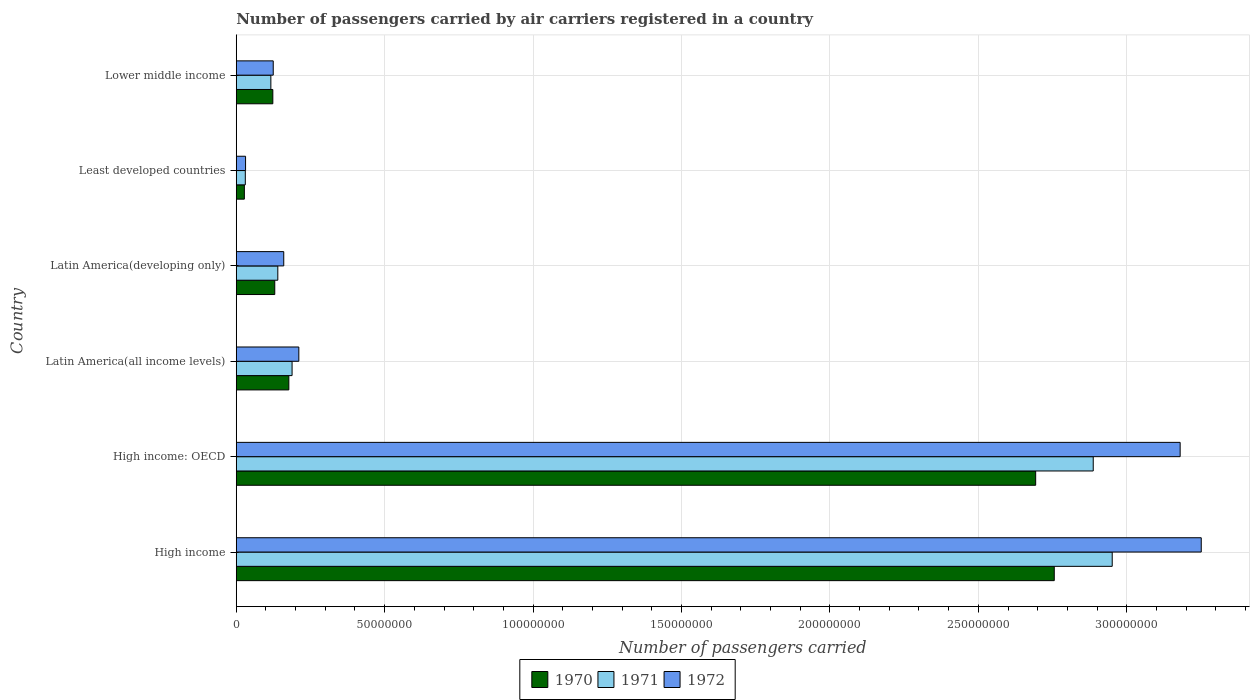Are the number of bars per tick equal to the number of legend labels?
Ensure brevity in your answer.  Yes. How many bars are there on the 1st tick from the top?
Your answer should be compact. 3. What is the label of the 5th group of bars from the top?
Make the answer very short. High income: OECD. What is the number of passengers carried by air carriers in 1971 in Latin America(developing only)?
Give a very brief answer. 1.40e+07. Across all countries, what is the maximum number of passengers carried by air carriers in 1970?
Provide a succinct answer. 2.76e+08. Across all countries, what is the minimum number of passengers carried by air carriers in 1972?
Your answer should be compact. 3.14e+06. In which country was the number of passengers carried by air carriers in 1972 maximum?
Ensure brevity in your answer.  High income. In which country was the number of passengers carried by air carriers in 1970 minimum?
Offer a terse response. Least developed countries. What is the total number of passengers carried by air carriers in 1970 in the graph?
Keep it short and to the point. 5.91e+08. What is the difference between the number of passengers carried by air carriers in 1972 in High income and that in Lower middle income?
Ensure brevity in your answer.  3.13e+08. What is the difference between the number of passengers carried by air carriers in 1970 in Latin America(all income levels) and the number of passengers carried by air carriers in 1972 in Latin America(developing only)?
Offer a terse response. 1.71e+06. What is the average number of passengers carried by air carriers in 1971 per country?
Your response must be concise. 1.05e+08. What is the difference between the number of passengers carried by air carriers in 1972 and number of passengers carried by air carriers in 1970 in Lower middle income?
Provide a short and direct response. 1.41e+05. What is the ratio of the number of passengers carried by air carriers in 1972 in Latin America(all income levels) to that in Least developed countries?
Your response must be concise. 6.72. Is the number of passengers carried by air carriers in 1970 in High income: OECD less than that in Lower middle income?
Keep it short and to the point. No. What is the difference between the highest and the second highest number of passengers carried by air carriers in 1970?
Offer a very short reply. 6.26e+06. What is the difference between the highest and the lowest number of passengers carried by air carriers in 1971?
Provide a short and direct response. 2.92e+08. Is the sum of the number of passengers carried by air carriers in 1970 in High income and Latin America(developing only) greater than the maximum number of passengers carried by air carriers in 1972 across all countries?
Your answer should be very brief. No. What does the 3rd bar from the top in Latin America(all income levels) represents?
Ensure brevity in your answer.  1970. What does the 1st bar from the bottom in High income represents?
Ensure brevity in your answer.  1970. How many bars are there?
Provide a succinct answer. 18. What is the difference between two consecutive major ticks on the X-axis?
Offer a terse response. 5.00e+07. How many legend labels are there?
Provide a short and direct response. 3. What is the title of the graph?
Give a very brief answer. Number of passengers carried by air carriers registered in a country. Does "1992" appear as one of the legend labels in the graph?
Provide a succinct answer. No. What is the label or title of the X-axis?
Provide a succinct answer. Number of passengers carried. What is the Number of passengers carried in 1970 in High income?
Your answer should be very brief. 2.76e+08. What is the Number of passengers carried of 1971 in High income?
Offer a terse response. 2.95e+08. What is the Number of passengers carried of 1972 in High income?
Ensure brevity in your answer.  3.25e+08. What is the Number of passengers carried of 1970 in High income: OECD?
Provide a succinct answer. 2.69e+08. What is the Number of passengers carried in 1971 in High income: OECD?
Offer a terse response. 2.89e+08. What is the Number of passengers carried in 1972 in High income: OECD?
Ensure brevity in your answer.  3.18e+08. What is the Number of passengers carried in 1970 in Latin America(all income levels)?
Offer a very short reply. 1.77e+07. What is the Number of passengers carried in 1971 in Latin America(all income levels)?
Offer a very short reply. 1.88e+07. What is the Number of passengers carried of 1972 in Latin America(all income levels)?
Your response must be concise. 2.11e+07. What is the Number of passengers carried of 1970 in Latin America(developing only)?
Your response must be concise. 1.30e+07. What is the Number of passengers carried in 1971 in Latin America(developing only)?
Your response must be concise. 1.40e+07. What is the Number of passengers carried of 1972 in Latin America(developing only)?
Offer a very short reply. 1.60e+07. What is the Number of passengers carried of 1970 in Least developed countries?
Your answer should be very brief. 2.73e+06. What is the Number of passengers carried of 1971 in Least developed countries?
Offer a very short reply. 3.05e+06. What is the Number of passengers carried of 1972 in Least developed countries?
Provide a succinct answer. 3.14e+06. What is the Number of passengers carried in 1970 in Lower middle income?
Make the answer very short. 1.23e+07. What is the Number of passengers carried of 1971 in Lower middle income?
Give a very brief answer. 1.17e+07. What is the Number of passengers carried of 1972 in Lower middle income?
Your answer should be compact. 1.25e+07. Across all countries, what is the maximum Number of passengers carried of 1970?
Keep it short and to the point. 2.76e+08. Across all countries, what is the maximum Number of passengers carried in 1971?
Offer a very short reply. 2.95e+08. Across all countries, what is the maximum Number of passengers carried of 1972?
Your answer should be compact. 3.25e+08. Across all countries, what is the minimum Number of passengers carried of 1970?
Offer a very short reply. 2.73e+06. Across all countries, what is the minimum Number of passengers carried in 1971?
Provide a short and direct response. 3.05e+06. Across all countries, what is the minimum Number of passengers carried of 1972?
Your answer should be very brief. 3.14e+06. What is the total Number of passengers carried of 1970 in the graph?
Keep it short and to the point. 5.91e+08. What is the total Number of passengers carried in 1971 in the graph?
Provide a short and direct response. 6.31e+08. What is the total Number of passengers carried in 1972 in the graph?
Your response must be concise. 6.96e+08. What is the difference between the Number of passengers carried in 1970 in High income and that in High income: OECD?
Ensure brevity in your answer.  6.26e+06. What is the difference between the Number of passengers carried of 1971 in High income and that in High income: OECD?
Give a very brief answer. 6.40e+06. What is the difference between the Number of passengers carried of 1972 in High income and that in High income: OECD?
Keep it short and to the point. 7.11e+06. What is the difference between the Number of passengers carried of 1970 in High income and that in Latin America(all income levels)?
Offer a very short reply. 2.58e+08. What is the difference between the Number of passengers carried in 1971 in High income and that in Latin America(all income levels)?
Make the answer very short. 2.76e+08. What is the difference between the Number of passengers carried of 1972 in High income and that in Latin America(all income levels)?
Your response must be concise. 3.04e+08. What is the difference between the Number of passengers carried in 1970 in High income and that in Latin America(developing only)?
Provide a succinct answer. 2.63e+08. What is the difference between the Number of passengers carried of 1971 in High income and that in Latin America(developing only)?
Provide a succinct answer. 2.81e+08. What is the difference between the Number of passengers carried of 1972 in High income and that in Latin America(developing only)?
Provide a succinct answer. 3.09e+08. What is the difference between the Number of passengers carried in 1970 in High income and that in Least developed countries?
Give a very brief answer. 2.73e+08. What is the difference between the Number of passengers carried in 1971 in High income and that in Least developed countries?
Your answer should be very brief. 2.92e+08. What is the difference between the Number of passengers carried of 1972 in High income and that in Least developed countries?
Make the answer very short. 3.22e+08. What is the difference between the Number of passengers carried of 1970 in High income and that in Lower middle income?
Your response must be concise. 2.63e+08. What is the difference between the Number of passengers carried of 1971 in High income and that in Lower middle income?
Provide a short and direct response. 2.83e+08. What is the difference between the Number of passengers carried in 1972 in High income and that in Lower middle income?
Keep it short and to the point. 3.13e+08. What is the difference between the Number of passengers carried in 1970 in High income: OECD and that in Latin America(all income levels)?
Your answer should be very brief. 2.52e+08. What is the difference between the Number of passengers carried in 1971 in High income: OECD and that in Latin America(all income levels)?
Your answer should be very brief. 2.70e+08. What is the difference between the Number of passengers carried in 1972 in High income: OECD and that in Latin America(all income levels)?
Your response must be concise. 2.97e+08. What is the difference between the Number of passengers carried of 1970 in High income: OECD and that in Latin America(developing only)?
Offer a terse response. 2.56e+08. What is the difference between the Number of passengers carried of 1971 in High income: OECD and that in Latin America(developing only)?
Give a very brief answer. 2.75e+08. What is the difference between the Number of passengers carried in 1972 in High income: OECD and that in Latin America(developing only)?
Make the answer very short. 3.02e+08. What is the difference between the Number of passengers carried of 1970 in High income: OECD and that in Least developed countries?
Give a very brief answer. 2.67e+08. What is the difference between the Number of passengers carried of 1971 in High income: OECD and that in Least developed countries?
Provide a succinct answer. 2.86e+08. What is the difference between the Number of passengers carried of 1972 in High income: OECD and that in Least developed countries?
Provide a succinct answer. 3.15e+08. What is the difference between the Number of passengers carried in 1970 in High income: OECD and that in Lower middle income?
Keep it short and to the point. 2.57e+08. What is the difference between the Number of passengers carried of 1971 in High income: OECD and that in Lower middle income?
Offer a terse response. 2.77e+08. What is the difference between the Number of passengers carried in 1972 in High income: OECD and that in Lower middle income?
Your answer should be very brief. 3.06e+08. What is the difference between the Number of passengers carried in 1970 in Latin America(all income levels) and that in Latin America(developing only)?
Provide a succinct answer. 4.74e+06. What is the difference between the Number of passengers carried in 1971 in Latin America(all income levels) and that in Latin America(developing only)?
Your response must be concise. 4.81e+06. What is the difference between the Number of passengers carried in 1972 in Latin America(all income levels) and that in Latin America(developing only)?
Offer a terse response. 5.08e+06. What is the difference between the Number of passengers carried of 1970 in Latin America(all income levels) and that in Least developed countries?
Provide a succinct answer. 1.50e+07. What is the difference between the Number of passengers carried in 1971 in Latin America(all income levels) and that in Least developed countries?
Offer a terse response. 1.58e+07. What is the difference between the Number of passengers carried of 1972 in Latin America(all income levels) and that in Least developed countries?
Make the answer very short. 1.79e+07. What is the difference between the Number of passengers carried in 1970 in Latin America(all income levels) and that in Lower middle income?
Offer a terse response. 5.40e+06. What is the difference between the Number of passengers carried of 1971 in Latin America(all income levels) and that in Lower middle income?
Provide a succinct answer. 7.15e+06. What is the difference between the Number of passengers carried of 1972 in Latin America(all income levels) and that in Lower middle income?
Keep it short and to the point. 8.62e+06. What is the difference between the Number of passengers carried in 1970 in Latin America(developing only) and that in Least developed countries?
Make the answer very short. 1.02e+07. What is the difference between the Number of passengers carried of 1971 in Latin America(developing only) and that in Least developed countries?
Provide a succinct answer. 1.09e+07. What is the difference between the Number of passengers carried in 1972 in Latin America(developing only) and that in Least developed countries?
Offer a very short reply. 1.29e+07. What is the difference between the Number of passengers carried in 1970 in Latin America(developing only) and that in Lower middle income?
Provide a short and direct response. 6.57e+05. What is the difference between the Number of passengers carried of 1971 in Latin America(developing only) and that in Lower middle income?
Make the answer very short. 2.35e+06. What is the difference between the Number of passengers carried of 1972 in Latin America(developing only) and that in Lower middle income?
Your answer should be very brief. 3.54e+06. What is the difference between the Number of passengers carried of 1970 in Least developed countries and that in Lower middle income?
Offer a terse response. -9.59e+06. What is the difference between the Number of passengers carried of 1971 in Least developed countries and that in Lower middle income?
Your answer should be very brief. -8.60e+06. What is the difference between the Number of passengers carried of 1972 in Least developed countries and that in Lower middle income?
Make the answer very short. -9.32e+06. What is the difference between the Number of passengers carried in 1970 in High income and the Number of passengers carried in 1971 in High income: OECD?
Your answer should be compact. -1.31e+07. What is the difference between the Number of passengers carried of 1970 in High income and the Number of passengers carried of 1972 in High income: OECD?
Offer a terse response. -4.24e+07. What is the difference between the Number of passengers carried of 1971 in High income and the Number of passengers carried of 1972 in High income: OECD?
Offer a very short reply. -2.29e+07. What is the difference between the Number of passengers carried in 1970 in High income and the Number of passengers carried in 1971 in Latin America(all income levels)?
Ensure brevity in your answer.  2.57e+08. What is the difference between the Number of passengers carried of 1970 in High income and the Number of passengers carried of 1972 in Latin America(all income levels)?
Offer a very short reply. 2.55e+08. What is the difference between the Number of passengers carried of 1971 in High income and the Number of passengers carried of 1972 in Latin America(all income levels)?
Provide a succinct answer. 2.74e+08. What is the difference between the Number of passengers carried in 1970 in High income and the Number of passengers carried in 1971 in Latin America(developing only)?
Your response must be concise. 2.62e+08. What is the difference between the Number of passengers carried of 1970 in High income and the Number of passengers carried of 1972 in Latin America(developing only)?
Ensure brevity in your answer.  2.60e+08. What is the difference between the Number of passengers carried of 1971 in High income and the Number of passengers carried of 1972 in Latin America(developing only)?
Offer a very short reply. 2.79e+08. What is the difference between the Number of passengers carried of 1970 in High income and the Number of passengers carried of 1971 in Least developed countries?
Ensure brevity in your answer.  2.73e+08. What is the difference between the Number of passengers carried of 1970 in High income and the Number of passengers carried of 1972 in Least developed countries?
Offer a terse response. 2.72e+08. What is the difference between the Number of passengers carried of 1971 in High income and the Number of passengers carried of 1972 in Least developed countries?
Keep it short and to the point. 2.92e+08. What is the difference between the Number of passengers carried of 1970 in High income and the Number of passengers carried of 1971 in Lower middle income?
Offer a very short reply. 2.64e+08. What is the difference between the Number of passengers carried of 1970 in High income and the Number of passengers carried of 1972 in Lower middle income?
Provide a short and direct response. 2.63e+08. What is the difference between the Number of passengers carried of 1971 in High income and the Number of passengers carried of 1972 in Lower middle income?
Ensure brevity in your answer.  2.83e+08. What is the difference between the Number of passengers carried in 1970 in High income: OECD and the Number of passengers carried in 1971 in Latin America(all income levels)?
Offer a very short reply. 2.51e+08. What is the difference between the Number of passengers carried of 1970 in High income: OECD and the Number of passengers carried of 1972 in Latin America(all income levels)?
Give a very brief answer. 2.48e+08. What is the difference between the Number of passengers carried in 1971 in High income: OECD and the Number of passengers carried in 1972 in Latin America(all income levels)?
Provide a short and direct response. 2.68e+08. What is the difference between the Number of passengers carried in 1970 in High income: OECD and the Number of passengers carried in 1971 in Latin America(developing only)?
Your answer should be very brief. 2.55e+08. What is the difference between the Number of passengers carried in 1970 in High income: OECD and the Number of passengers carried in 1972 in Latin America(developing only)?
Your answer should be compact. 2.53e+08. What is the difference between the Number of passengers carried of 1971 in High income: OECD and the Number of passengers carried of 1972 in Latin America(developing only)?
Ensure brevity in your answer.  2.73e+08. What is the difference between the Number of passengers carried of 1970 in High income: OECD and the Number of passengers carried of 1971 in Least developed countries?
Offer a very short reply. 2.66e+08. What is the difference between the Number of passengers carried of 1970 in High income: OECD and the Number of passengers carried of 1972 in Least developed countries?
Offer a very short reply. 2.66e+08. What is the difference between the Number of passengers carried of 1971 in High income: OECD and the Number of passengers carried of 1972 in Least developed countries?
Keep it short and to the point. 2.86e+08. What is the difference between the Number of passengers carried in 1970 in High income: OECD and the Number of passengers carried in 1971 in Lower middle income?
Give a very brief answer. 2.58e+08. What is the difference between the Number of passengers carried of 1970 in High income: OECD and the Number of passengers carried of 1972 in Lower middle income?
Give a very brief answer. 2.57e+08. What is the difference between the Number of passengers carried of 1971 in High income: OECD and the Number of passengers carried of 1972 in Lower middle income?
Offer a very short reply. 2.76e+08. What is the difference between the Number of passengers carried in 1970 in Latin America(all income levels) and the Number of passengers carried in 1971 in Latin America(developing only)?
Your response must be concise. 3.71e+06. What is the difference between the Number of passengers carried of 1970 in Latin America(all income levels) and the Number of passengers carried of 1972 in Latin America(developing only)?
Provide a short and direct response. 1.71e+06. What is the difference between the Number of passengers carried in 1971 in Latin America(all income levels) and the Number of passengers carried in 1972 in Latin America(developing only)?
Offer a terse response. 2.81e+06. What is the difference between the Number of passengers carried in 1970 in Latin America(all income levels) and the Number of passengers carried in 1971 in Least developed countries?
Your answer should be very brief. 1.47e+07. What is the difference between the Number of passengers carried in 1970 in Latin America(all income levels) and the Number of passengers carried in 1972 in Least developed countries?
Offer a terse response. 1.46e+07. What is the difference between the Number of passengers carried in 1971 in Latin America(all income levels) and the Number of passengers carried in 1972 in Least developed countries?
Your answer should be compact. 1.57e+07. What is the difference between the Number of passengers carried in 1970 in Latin America(all income levels) and the Number of passengers carried in 1971 in Lower middle income?
Keep it short and to the point. 6.06e+06. What is the difference between the Number of passengers carried in 1970 in Latin America(all income levels) and the Number of passengers carried in 1972 in Lower middle income?
Your answer should be compact. 5.26e+06. What is the difference between the Number of passengers carried in 1971 in Latin America(all income levels) and the Number of passengers carried in 1972 in Lower middle income?
Your answer should be very brief. 6.35e+06. What is the difference between the Number of passengers carried in 1970 in Latin America(developing only) and the Number of passengers carried in 1971 in Least developed countries?
Provide a short and direct response. 9.92e+06. What is the difference between the Number of passengers carried in 1970 in Latin America(developing only) and the Number of passengers carried in 1972 in Least developed countries?
Provide a short and direct response. 9.84e+06. What is the difference between the Number of passengers carried in 1971 in Latin America(developing only) and the Number of passengers carried in 1972 in Least developed countries?
Make the answer very short. 1.09e+07. What is the difference between the Number of passengers carried of 1970 in Latin America(developing only) and the Number of passengers carried of 1971 in Lower middle income?
Your response must be concise. 1.32e+06. What is the difference between the Number of passengers carried in 1970 in Latin America(developing only) and the Number of passengers carried in 1972 in Lower middle income?
Offer a terse response. 5.16e+05. What is the difference between the Number of passengers carried of 1971 in Latin America(developing only) and the Number of passengers carried of 1972 in Lower middle income?
Give a very brief answer. 1.54e+06. What is the difference between the Number of passengers carried of 1970 in Least developed countries and the Number of passengers carried of 1971 in Lower middle income?
Ensure brevity in your answer.  -8.93e+06. What is the difference between the Number of passengers carried of 1970 in Least developed countries and the Number of passengers carried of 1972 in Lower middle income?
Provide a short and direct response. -9.73e+06. What is the difference between the Number of passengers carried in 1971 in Least developed countries and the Number of passengers carried in 1972 in Lower middle income?
Your answer should be compact. -9.41e+06. What is the average Number of passengers carried in 1970 per country?
Offer a very short reply. 9.84e+07. What is the average Number of passengers carried of 1971 per country?
Your response must be concise. 1.05e+08. What is the average Number of passengers carried of 1972 per country?
Offer a very short reply. 1.16e+08. What is the difference between the Number of passengers carried in 1970 and Number of passengers carried in 1971 in High income?
Ensure brevity in your answer.  -1.95e+07. What is the difference between the Number of passengers carried of 1970 and Number of passengers carried of 1972 in High income?
Give a very brief answer. -4.95e+07. What is the difference between the Number of passengers carried in 1971 and Number of passengers carried in 1972 in High income?
Keep it short and to the point. -3.00e+07. What is the difference between the Number of passengers carried in 1970 and Number of passengers carried in 1971 in High income: OECD?
Keep it short and to the point. -1.94e+07. What is the difference between the Number of passengers carried of 1970 and Number of passengers carried of 1972 in High income: OECD?
Your response must be concise. -4.87e+07. What is the difference between the Number of passengers carried in 1971 and Number of passengers carried in 1972 in High income: OECD?
Keep it short and to the point. -2.93e+07. What is the difference between the Number of passengers carried in 1970 and Number of passengers carried in 1971 in Latin America(all income levels)?
Give a very brief answer. -1.09e+06. What is the difference between the Number of passengers carried of 1970 and Number of passengers carried of 1972 in Latin America(all income levels)?
Your response must be concise. -3.36e+06. What is the difference between the Number of passengers carried of 1971 and Number of passengers carried of 1972 in Latin America(all income levels)?
Provide a short and direct response. -2.27e+06. What is the difference between the Number of passengers carried of 1970 and Number of passengers carried of 1971 in Latin America(developing only)?
Keep it short and to the point. -1.03e+06. What is the difference between the Number of passengers carried of 1970 and Number of passengers carried of 1972 in Latin America(developing only)?
Provide a succinct answer. -3.03e+06. What is the difference between the Number of passengers carried of 1971 and Number of passengers carried of 1972 in Latin America(developing only)?
Your answer should be compact. -2.00e+06. What is the difference between the Number of passengers carried of 1970 and Number of passengers carried of 1971 in Least developed countries?
Ensure brevity in your answer.  -3.23e+05. What is the difference between the Number of passengers carried of 1970 and Number of passengers carried of 1972 in Least developed countries?
Provide a succinct answer. -4.07e+05. What is the difference between the Number of passengers carried of 1971 and Number of passengers carried of 1972 in Least developed countries?
Your answer should be compact. -8.41e+04. What is the difference between the Number of passengers carried in 1970 and Number of passengers carried in 1971 in Lower middle income?
Your answer should be very brief. 6.64e+05. What is the difference between the Number of passengers carried in 1970 and Number of passengers carried in 1972 in Lower middle income?
Your answer should be very brief. -1.41e+05. What is the difference between the Number of passengers carried in 1971 and Number of passengers carried in 1972 in Lower middle income?
Give a very brief answer. -8.05e+05. What is the ratio of the Number of passengers carried in 1970 in High income to that in High income: OECD?
Make the answer very short. 1.02. What is the ratio of the Number of passengers carried in 1971 in High income to that in High income: OECD?
Provide a succinct answer. 1.02. What is the ratio of the Number of passengers carried in 1972 in High income to that in High income: OECD?
Ensure brevity in your answer.  1.02. What is the ratio of the Number of passengers carried in 1970 in High income to that in Latin America(all income levels)?
Ensure brevity in your answer.  15.55. What is the ratio of the Number of passengers carried in 1971 in High income to that in Latin America(all income levels)?
Keep it short and to the point. 15.69. What is the ratio of the Number of passengers carried in 1972 in High income to that in Latin America(all income levels)?
Keep it short and to the point. 15.42. What is the ratio of the Number of passengers carried of 1970 in High income to that in Latin America(developing only)?
Your answer should be compact. 21.24. What is the ratio of the Number of passengers carried in 1971 in High income to that in Latin America(developing only)?
Give a very brief answer. 21.07. What is the ratio of the Number of passengers carried of 1972 in High income to that in Latin America(developing only)?
Your answer should be compact. 20.31. What is the ratio of the Number of passengers carried in 1970 in High income to that in Least developed countries?
Provide a short and direct response. 100.92. What is the ratio of the Number of passengers carried of 1971 in High income to that in Least developed countries?
Provide a short and direct response. 96.63. What is the ratio of the Number of passengers carried in 1972 in High income to that in Least developed countries?
Provide a short and direct response. 103.6. What is the ratio of the Number of passengers carried in 1970 in High income to that in Lower middle income?
Your response must be concise. 22.37. What is the ratio of the Number of passengers carried of 1971 in High income to that in Lower middle income?
Offer a very short reply. 25.32. What is the ratio of the Number of passengers carried of 1972 in High income to that in Lower middle income?
Provide a succinct answer. 26.09. What is the ratio of the Number of passengers carried in 1970 in High income: OECD to that in Latin America(all income levels)?
Provide a short and direct response. 15.2. What is the ratio of the Number of passengers carried in 1971 in High income: OECD to that in Latin America(all income levels)?
Ensure brevity in your answer.  15.35. What is the ratio of the Number of passengers carried in 1972 in High income: OECD to that in Latin America(all income levels)?
Make the answer very short. 15.09. What is the ratio of the Number of passengers carried of 1970 in High income: OECD to that in Latin America(developing only)?
Your response must be concise. 20.75. What is the ratio of the Number of passengers carried in 1971 in High income: OECD to that in Latin America(developing only)?
Offer a terse response. 20.62. What is the ratio of the Number of passengers carried of 1972 in High income: OECD to that in Latin America(developing only)?
Provide a succinct answer. 19.87. What is the ratio of the Number of passengers carried of 1970 in High income: OECD to that in Least developed countries?
Your answer should be very brief. 98.62. What is the ratio of the Number of passengers carried in 1971 in High income: OECD to that in Least developed countries?
Provide a short and direct response. 94.54. What is the ratio of the Number of passengers carried in 1972 in High income: OECD to that in Least developed countries?
Offer a very short reply. 101.33. What is the ratio of the Number of passengers carried in 1970 in High income: OECD to that in Lower middle income?
Offer a terse response. 21.86. What is the ratio of the Number of passengers carried in 1971 in High income: OECD to that in Lower middle income?
Provide a short and direct response. 24.77. What is the ratio of the Number of passengers carried in 1972 in High income: OECD to that in Lower middle income?
Offer a terse response. 25.52. What is the ratio of the Number of passengers carried in 1970 in Latin America(all income levels) to that in Latin America(developing only)?
Your answer should be compact. 1.37. What is the ratio of the Number of passengers carried of 1971 in Latin America(all income levels) to that in Latin America(developing only)?
Your answer should be very brief. 1.34. What is the ratio of the Number of passengers carried of 1972 in Latin America(all income levels) to that in Latin America(developing only)?
Ensure brevity in your answer.  1.32. What is the ratio of the Number of passengers carried of 1970 in Latin America(all income levels) to that in Least developed countries?
Your answer should be very brief. 6.49. What is the ratio of the Number of passengers carried of 1971 in Latin America(all income levels) to that in Least developed countries?
Give a very brief answer. 6.16. What is the ratio of the Number of passengers carried of 1972 in Latin America(all income levels) to that in Least developed countries?
Keep it short and to the point. 6.72. What is the ratio of the Number of passengers carried in 1970 in Latin America(all income levels) to that in Lower middle income?
Provide a short and direct response. 1.44. What is the ratio of the Number of passengers carried in 1971 in Latin America(all income levels) to that in Lower middle income?
Your answer should be very brief. 1.61. What is the ratio of the Number of passengers carried of 1972 in Latin America(all income levels) to that in Lower middle income?
Offer a terse response. 1.69. What is the ratio of the Number of passengers carried of 1970 in Latin America(developing only) to that in Least developed countries?
Make the answer very short. 4.75. What is the ratio of the Number of passengers carried in 1971 in Latin America(developing only) to that in Least developed countries?
Offer a terse response. 4.59. What is the ratio of the Number of passengers carried in 1972 in Latin America(developing only) to that in Least developed countries?
Your answer should be very brief. 5.1. What is the ratio of the Number of passengers carried of 1970 in Latin America(developing only) to that in Lower middle income?
Provide a succinct answer. 1.05. What is the ratio of the Number of passengers carried in 1971 in Latin America(developing only) to that in Lower middle income?
Make the answer very short. 1.2. What is the ratio of the Number of passengers carried in 1972 in Latin America(developing only) to that in Lower middle income?
Give a very brief answer. 1.28. What is the ratio of the Number of passengers carried in 1970 in Least developed countries to that in Lower middle income?
Your answer should be compact. 0.22. What is the ratio of the Number of passengers carried of 1971 in Least developed countries to that in Lower middle income?
Make the answer very short. 0.26. What is the ratio of the Number of passengers carried of 1972 in Least developed countries to that in Lower middle income?
Your answer should be very brief. 0.25. What is the difference between the highest and the second highest Number of passengers carried of 1970?
Offer a terse response. 6.26e+06. What is the difference between the highest and the second highest Number of passengers carried in 1971?
Your response must be concise. 6.40e+06. What is the difference between the highest and the second highest Number of passengers carried of 1972?
Ensure brevity in your answer.  7.11e+06. What is the difference between the highest and the lowest Number of passengers carried of 1970?
Provide a short and direct response. 2.73e+08. What is the difference between the highest and the lowest Number of passengers carried of 1971?
Give a very brief answer. 2.92e+08. What is the difference between the highest and the lowest Number of passengers carried of 1972?
Keep it short and to the point. 3.22e+08. 